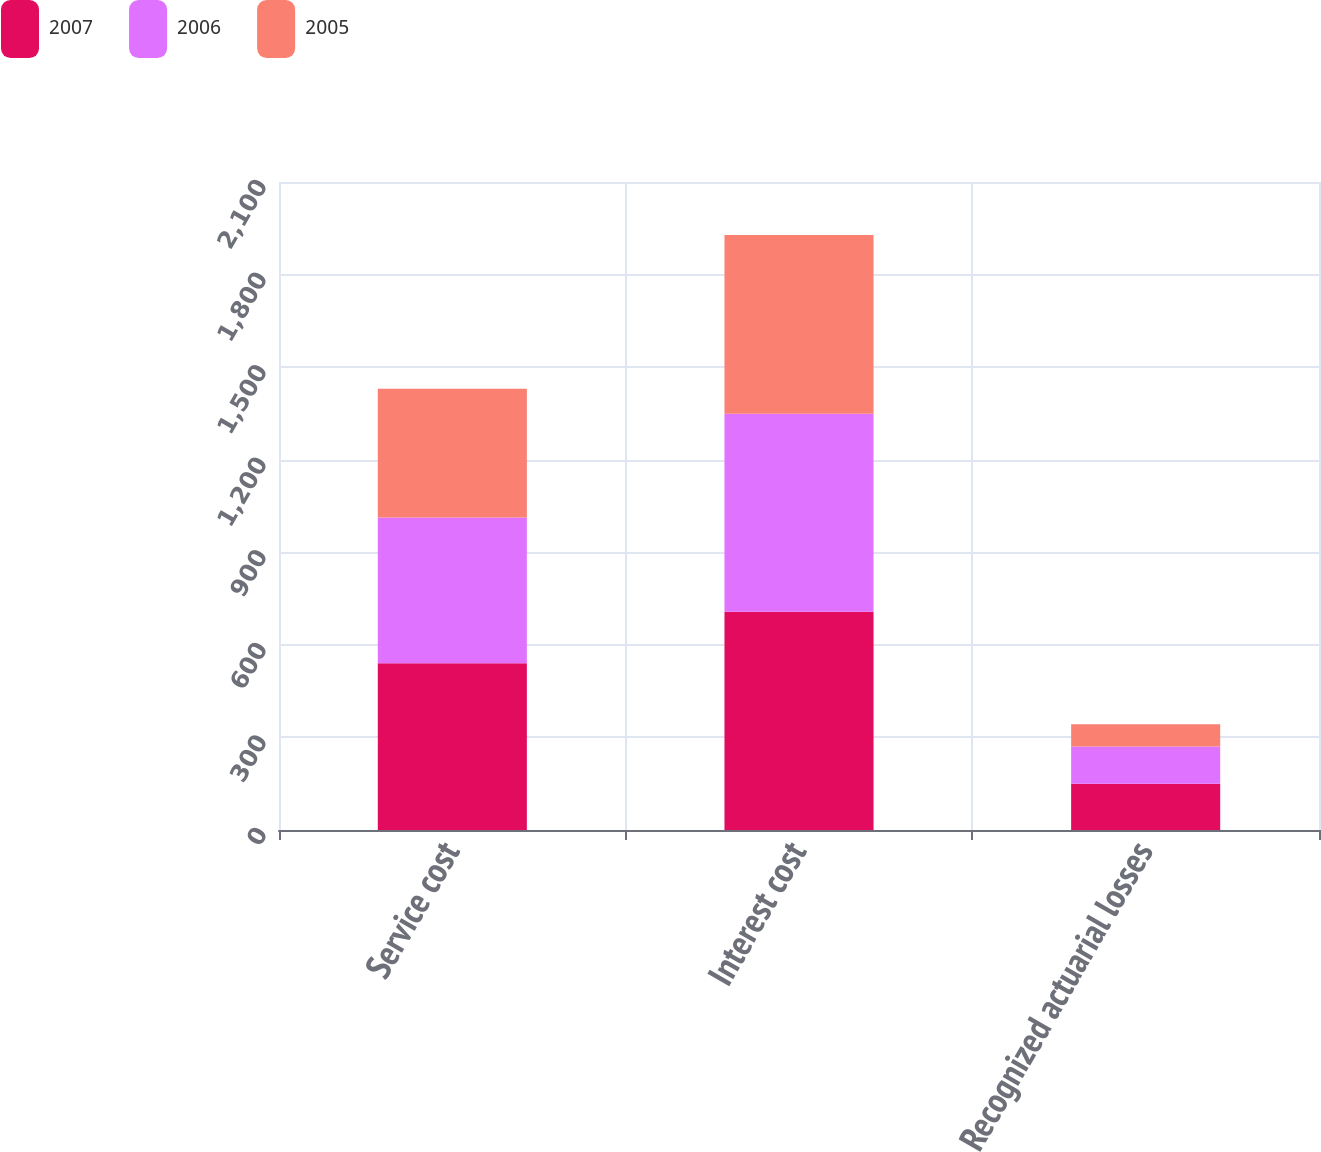<chart> <loc_0><loc_0><loc_500><loc_500><stacked_bar_chart><ecel><fcel>Service cost<fcel>Interest cost<fcel>Recognized actuarial losses<nl><fcel>2007<fcel>540<fcel>707<fcel>150<nl><fcel>2006<fcel>473<fcel>642<fcel>121<nl><fcel>2005<fcel>417<fcel>579<fcel>72<nl></chart> 